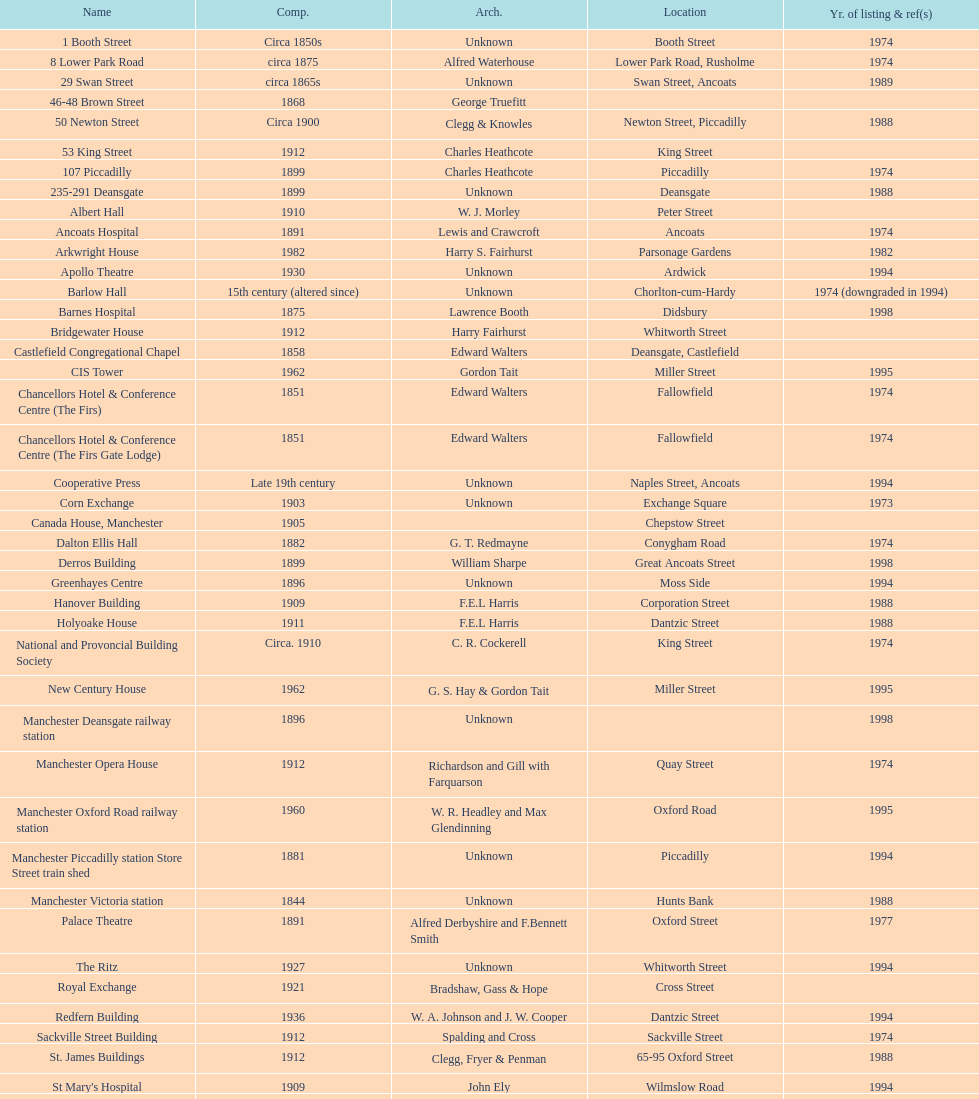Parse the table in full. {'header': ['Name', 'Comp.', 'Arch.', 'Location', 'Yr. of listing & ref(s)'], 'rows': [['1 Booth Street', 'Circa 1850s', 'Unknown', 'Booth Street', '1974'], ['8 Lower Park Road', 'circa 1875', 'Alfred Waterhouse', 'Lower Park Road, Rusholme', '1974'], ['29 Swan Street', 'circa 1865s', 'Unknown', 'Swan Street, Ancoats', '1989'], ['46-48 Brown Street', '1868', 'George Truefitt', '', ''], ['50 Newton Street', 'Circa 1900', 'Clegg & Knowles', 'Newton Street, Piccadilly', '1988'], ['53 King Street', '1912', 'Charles Heathcote', 'King Street', ''], ['107 Piccadilly', '1899', 'Charles Heathcote', 'Piccadilly', '1974'], ['235-291 Deansgate', '1899', 'Unknown', 'Deansgate', '1988'], ['Albert Hall', '1910', 'W. J. Morley', 'Peter Street', ''], ['Ancoats Hospital', '1891', 'Lewis and Crawcroft', 'Ancoats', '1974'], ['Arkwright House', '1982', 'Harry S. Fairhurst', 'Parsonage Gardens', '1982'], ['Apollo Theatre', '1930', 'Unknown', 'Ardwick', '1994'], ['Barlow Hall', '15th century (altered since)', 'Unknown', 'Chorlton-cum-Hardy', '1974 (downgraded in 1994)'], ['Barnes Hospital', '1875', 'Lawrence Booth', 'Didsbury', '1998'], ['Bridgewater House', '1912', 'Harry Fairhurst', 'Whitworth Street', ''], ['Castlefield Congregational Chapel', '1858', 'Edward Walters', 'Deansgate, Castlefield', ''], ['CIS Tower', '1962', 'Gordon Tait', 'Miller Street', '1995'], ['Chancellors Hotel & Conference Centre (The Firs)', '1851', 'Edward Walters', 'Fallowfield', '1974'], ['Chancellors Hotel & Conference Centre (The Firs Gate Lodge)', '1851', 'Edward Walters', 'Fallowfield', '1974'], ['Cooperative Press', 'Late 19th century', 'Unknown', 'Naples Street, Ancoats', '1994'], ['Corn Exchange', '1903', 'Unknown', 'Exchange Square', '1973'], ['Canada House, Manchester', '1905', '', 'Chepstow Street', ''], ['Dalton Ellis Hall', '1882', 'G. T. Redmayne', 'Conygham Road', '1974'], ['Derros Building', '1899', 'William Sharpe', 'Great Ancoats Street', '1998'], ['Greenhayes Centre', '1896', 'Unknown', 'Moss Side', '1994'], ['Hanover Building', '1909', 'F.E.L Harris', 'Corporation Street', '1988'], ['Holyoake House', '1911', 'F.E.L Harris', 'Dantzic Street', '1988'], ['National and Provoncial Building Society', 'Circa. 1910', 'C. R. Cockerell', 'King Street', '1974'], ['New Century House', '1962', 'G. S. Hay & Gordon Tait', 'Miller Street', '1995'], ['Manchester Deansgate railway station', '1896', 'Unknown', '', '1998'], ['Manchester Opera House', '1912', 'Richardson and Gill with Farquarson', 'Quay Street', '1974'], ['Manchester Oxford Road railway station', '1960', 'W. R. Headley and Max Glendinning', 'Oxford Road', '1995'], ['Manchester Piccadilly station Store Street train shed', '1881', 'Unknown', 'Piccadilly', '1994'], ['Manchester Victoria station', '1844', 'Unknown', 'Hunts Bank', '1988'], ['Palace Theatre', '1891', 'Alfred Derbyshire and F.Bennett Smith', 'Oxford Street', '1977'], ['The Ritz', '1927', 'Unknown', 'Whitworth Street', '1994'], ['Royal Exchange', '1921', 'Bradshaw, Gass & Hope', 'Cross Street', ''], ['Redfern Building', '1936', 'W. A. Johnson and J. W. Cooper', 'Dantzic Street', '1994'], ['Sackville Street Building', '1912', 'Spalding and Cross', 'Sackville Street', '1974'], ['St. James Buildings', '1912', 'Clegg, Fryer & Penman', '65-95 Oxford Street', '1988'], ["St Mary's Hospital", '1909', 'John Ely', 'Wilmslow Road', '1994'], ['Samuel Alexander Building', '1919', 'Percy Scott Worthington', 'Oxford Road', '2010'], ['Ship Canal House', '1927', 'Harry S. Fairhurst', 'King Street', '1982'], ['Smithfield Market Hall', '1857', 'Unknown', 'Swan Street, Ancoats', '1973'], ['Strangeways Gaol Gatehouse', '1868', 'Alfred Waterhouse', 'Sherborne Street', '1974'], ['Strangeways Prison ventilation and watch tower', '1868', 'Alfred Waterhouse', 'Sherborne Street', '1974'], ['Theatre Royal', '1845', 'Irwin and Chester', 'Peter Street', '1974'], ['Toast Rack', '1960', 'L. C. Howitt', 'Fallowfield', '1999'], ['The Old Wellington Inn', 'Mid-16th century', 'Unknown', 'Shambles Square', '1952'], ['Whitworth Park Mansions', 'Circa 1840s', 'Unknown', 'Whitworth Park', '1974']]} What quantity of buildings have no images included in their listing? 11. 